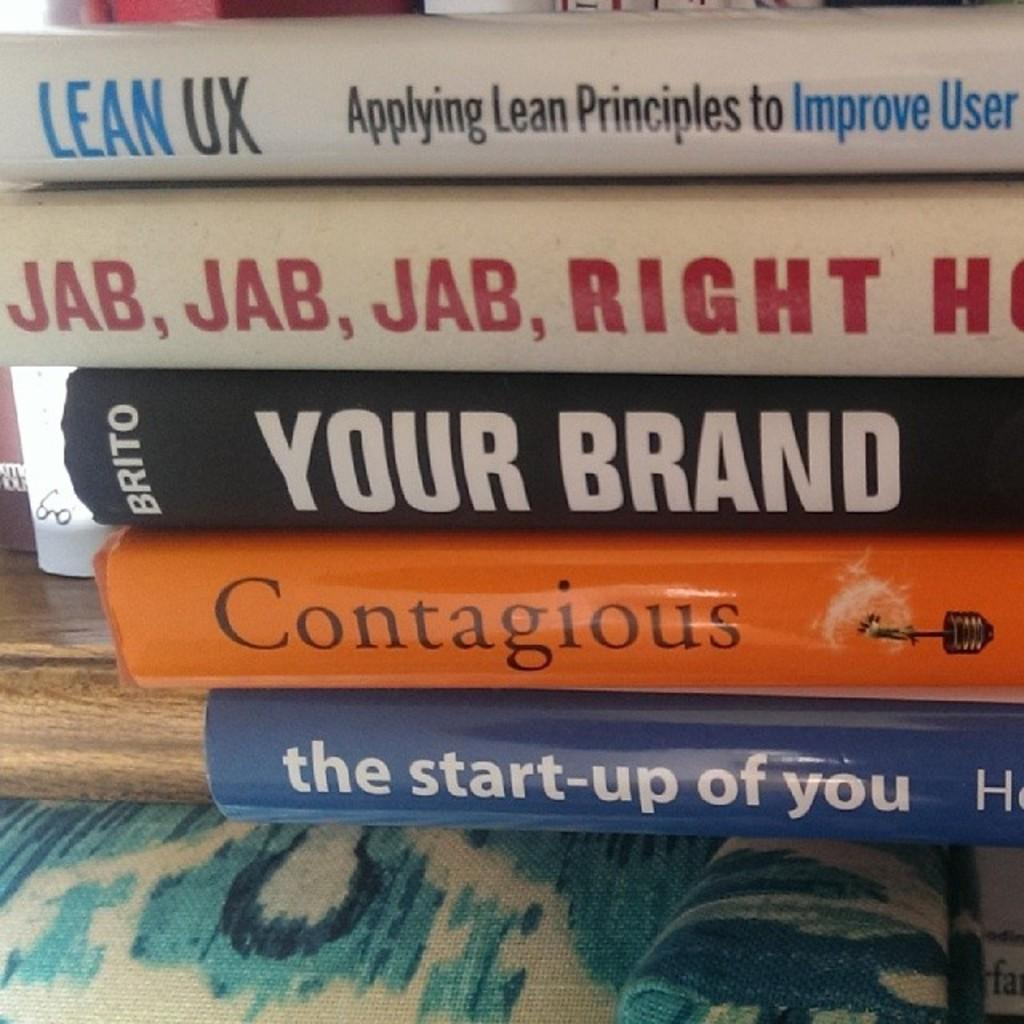<image>
Present a compact description of the photo's key features. Books on self improvement are stacked on top of each other. 